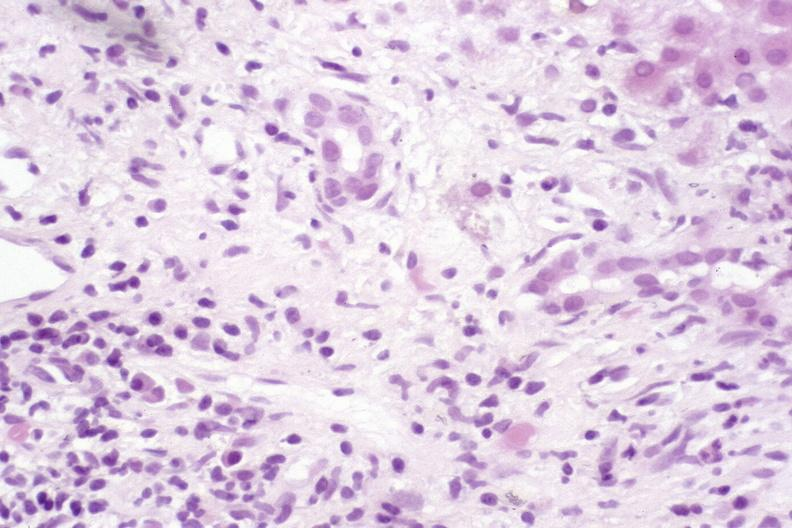what is present?
Answer the question using a single word or phrase. Hepatobiliary 